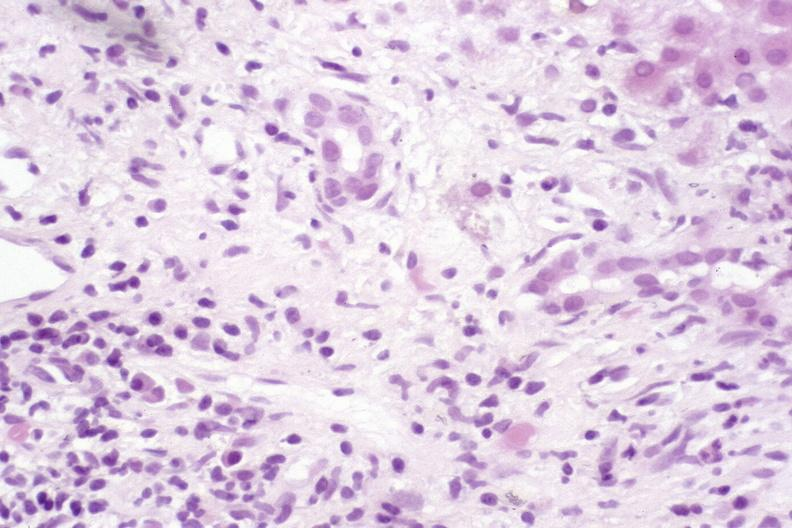what is present?
Answer the question using a single word or phrase. Hepatobiliary 